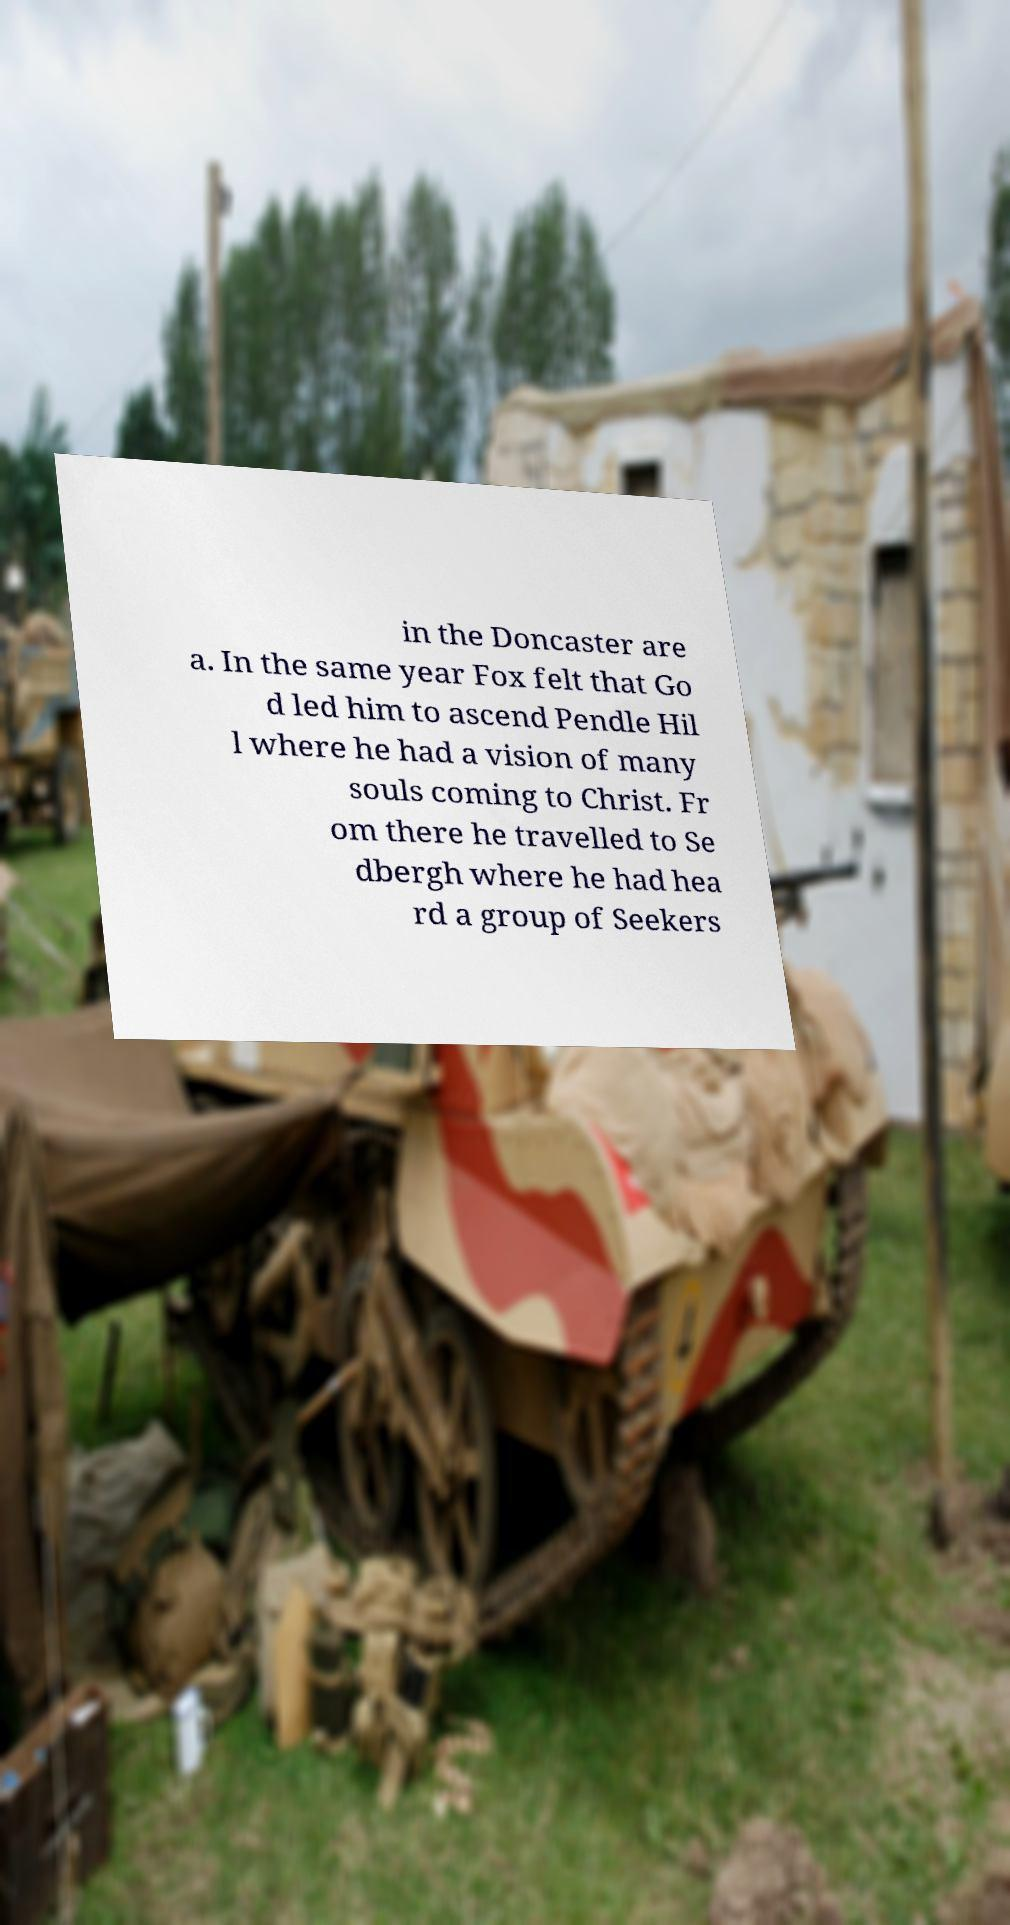I need the written content from this picture converted into text. Can you do that? in the Doncaster are a. In the same year Fox felt that Go d led him to ascend Pendle Hil l where he had a vision of many souls coming to Christ. Fr om there he travelled to Se dbergh where he had hea rd a group of Seekers 